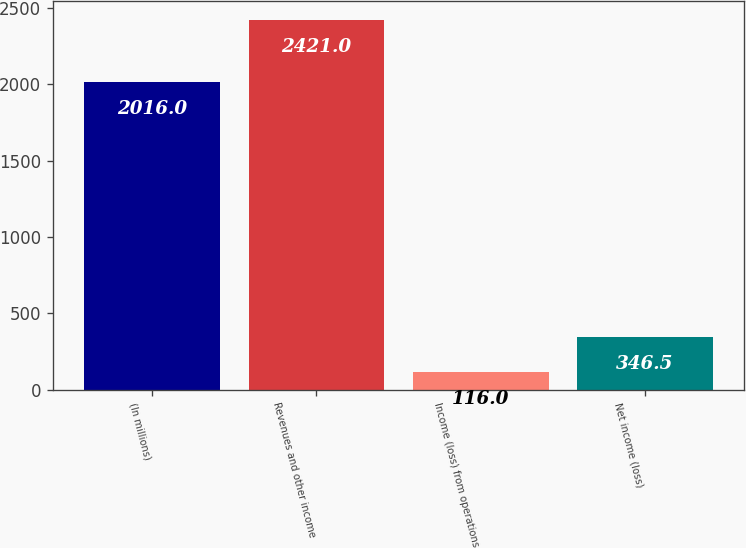Convert chart to OTSL. <chart><loc_0><loc_0><loc_500><loc_500><bar_chart><fcel>(In millions)<fcel>Revenues and other income<fcel>Income (loss) from operations<fcel>Net income (loss)<nl><fcel>2016<fcel>2421<fcel>116<fcel>346.5<nl></chart> 